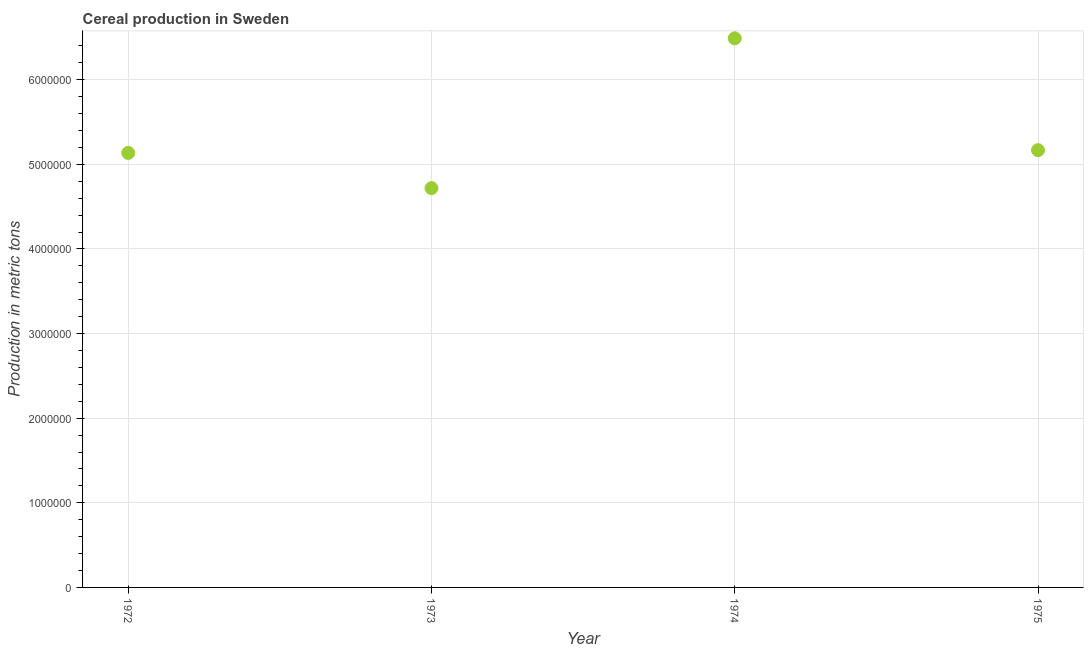What is the cereal production in 1973?
Give a very brief answer. 4.72e+06. Across all years, what is the maximum cereal production?
Give a very brief answer. 6.49e+06. Across all years, what is the minimum cereal production?
Provide a short and direct response. 4.72e+06. In which year was the cereal production maximum?
Keep it short and to the point. 1974. What is the sum of the cereal production?
Keep it short and to the point. 2.15e+07. What is the difference between the cereal production in 1974 and 1975?
Offer a very short reply. 1.32e+06. What is the average cereal production per year?
Your answer should be compact. 5.38e+06. What is the median cereal production?
Your answer should be very brief. 5.15e+06. What is the ratio of the cereal production in 1972 to that in 1975?
Ensure brevity in your answer.  0.99. Is the cereal production in 1973 less than that in 1974?
Provide a short and direct response. Yes. What is the difference between the highest and the second highest cereal production?
Provide a succinct answer. 1.32e+06. What is the difference between the highest and the lowest cereal production?
Offer a very short reply. 1.77e+06. In how many years, is the cereal production greater than the average cereal production taken over all years?
Your response must be concise. 1. Does the cereal production monotonically increase over the years?
Keep it short and to the point. No. How many dotlines are there?
Your answer should be compact. 1. How many years are there in the graph?
Offer a terse response. 4. Are the values on the major ticks of Y-axis written in scientific E-notation?
Your response must be concise. No. Does the graph contain grids?
Give a very brief answer. Yes. What is the title of the graph?
Give a very brief answer. Cereal production in Sweden. What is the label or title of the X-axis?
Your response must be concise. Year. What is the label or title of the Y-axis?
Provide a succinct answer. Production in metric tons. What is the Production in metric tons in 1972?
Your answer should be very brief. 5.14e+06. What is the Production in metric tons in 1973?
Provide a short and direct response. 4.72e+06. What is the Production in metric tons in 1974?
Ensure brevity in your answer.  6.49e+06. What is the Production in metric tons in 1975?
Give a very brief answer. 5.17e+06. What is the difference between the Production in metric tons in 1972 and 1973?
Make the answer very short. 4.16e+05. What is the difference between the Production in metric tons in 1972 and 1974?
Your response must be concise. -1.35e+06. What is the difference between the Production in metric tons in 1972 and 1975?
Your answer should be very brief. -3.22e+04. What is the difference between the Production in metric tons in 1973 and 1974?
Make the answer very short. -1.77e+06. What is the difference between the Production in metric tons in 1973 and 1975?
Provide a short and direct response. -4.48e+05. What is the difference between the Production in metric tons in 1974 and 1975?
Provide a short and direct response. 1.32e+06. What is the ratio of the Production in metric tons in 1972 to that in 1973?
Offer a terse response. 1.09. What is the ratio of the Production in metric tons in 1972 to that in 1974?
Provide a short and direct response. 0.79. What is the ratio of the Production in metric tons in 1973 to that in 1974?
Offer a terse response. 0.73. What is the ratio of the Production in metric tons in 1973 to that in 1975?
Offer a terse response. 0.91. What is the ratio of the Production in metric tons in 1974 to that in 1975?
Your answer should be very brief. 1.26. 